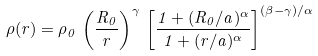Convert formula to latex. <formula><loc_0><loc_0><loc_500><loc_500>\rho ( r ) = \rho _ { 0 } \, \left ( \frac { R _ { 0 } } { r } \right ) ^ { \gamma } \, \left [ \frac { 1 + ( R _ { 0 } / a ) ^ { \alpha } } { 1 + ( r / a ) ^ { \alpha } } \right ] ^ { ( \beta - \gamma ) / \alpha }</formula> 